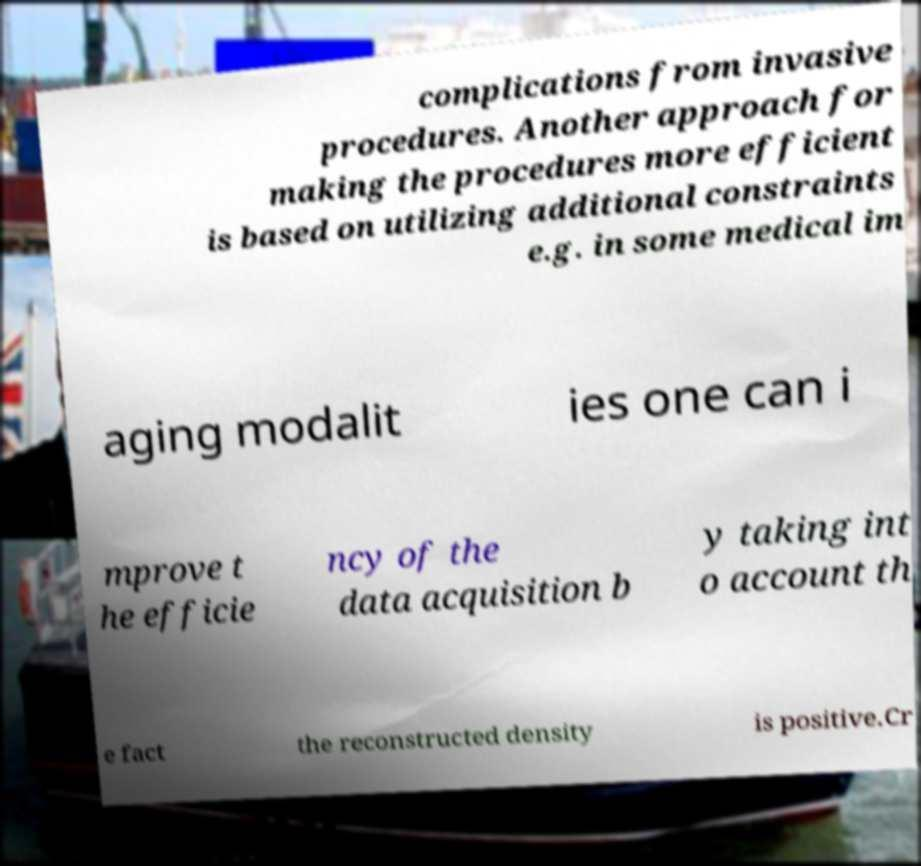Please read and relay the text visible in this image. What does it say? complications from invasive procedures. Another approach for making the procedures more efficient is based on utilizing additional constraints e.g. in some medical im aging modalit ies one can i mprove t he efficie ncy of the data acquisition b y taking int o account th e fact the reconstructed density is positive.Cr 